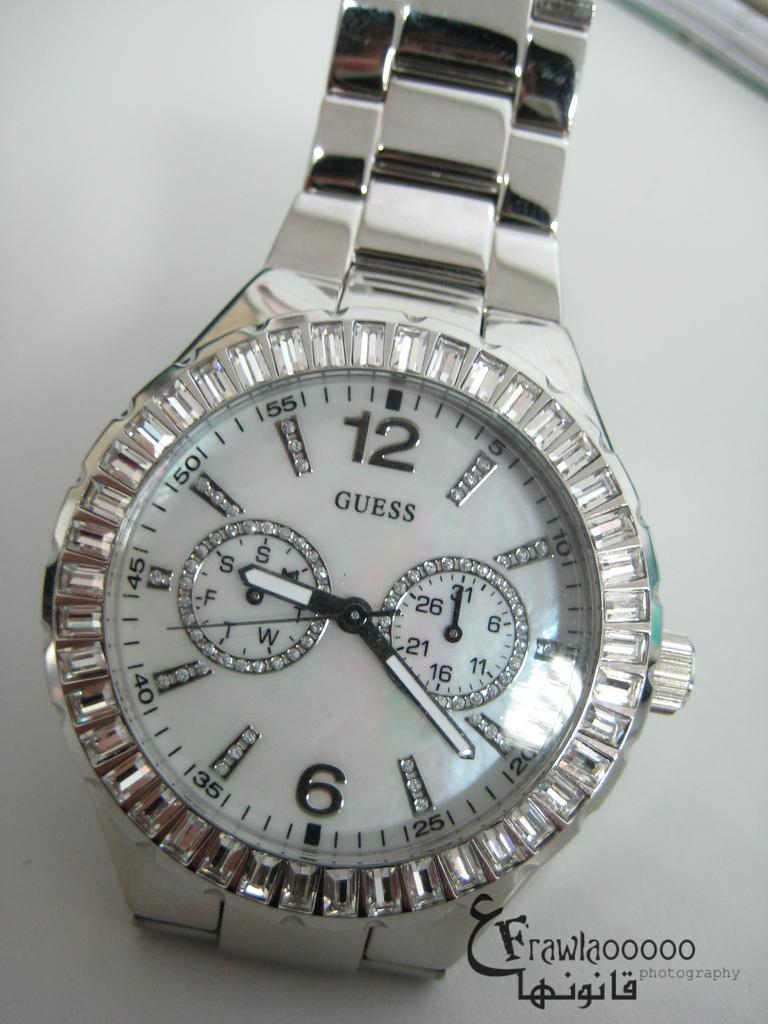Provide a one-sentence caption for the provided image. A Guess watch is on display on a counter. 